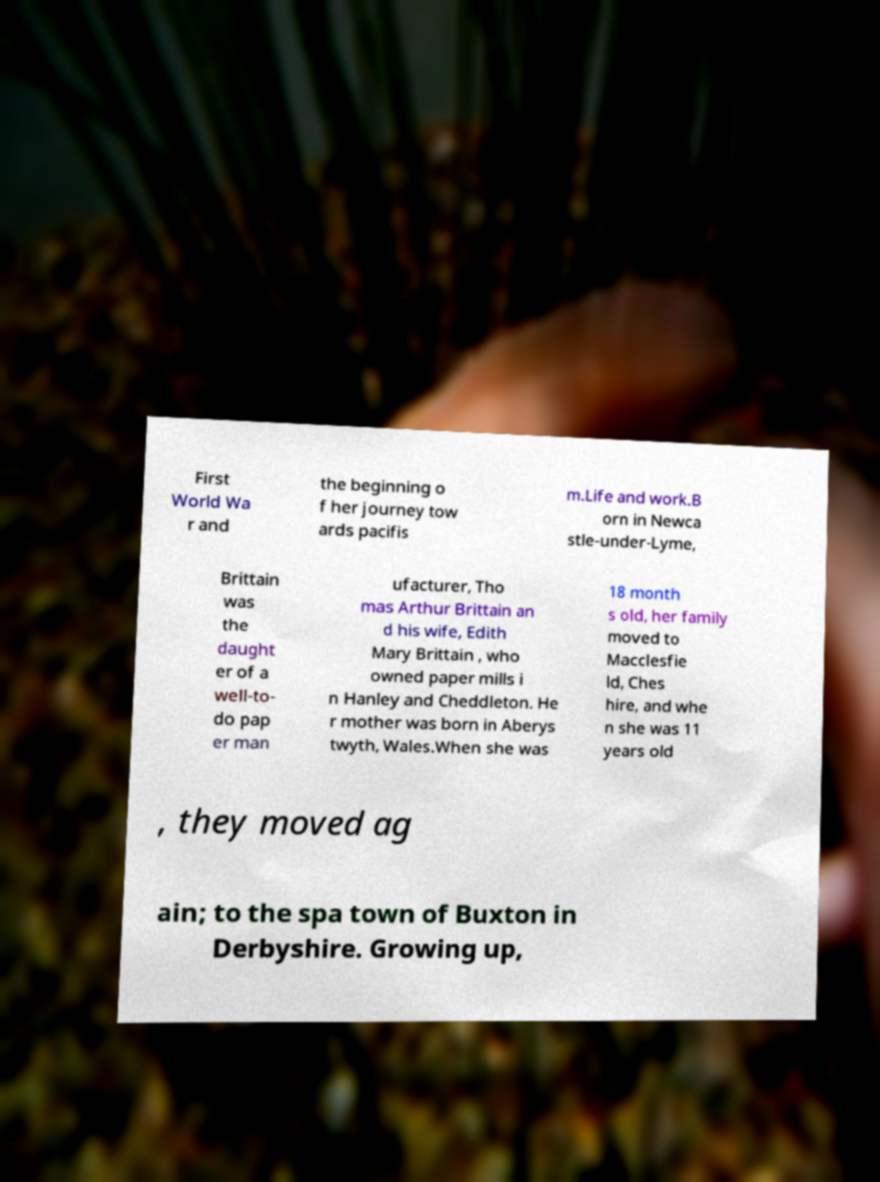Could you extract and type out the text from this image? First World Wa r and the beginning o f her journey tow ards pacifis m.Life and work.B orn in Newca stle-under-Lyme, Brittain was the daught er of a well-to- do pap er man ufacturer, Tho mas Arthur Brittain an d his wife, Edith Mary Brittain , who owned paper mills i n Hanley and Cheddleton. He r mother was born in Aberys twyth, Wales.When she was 18 month s old, her family moved to Macclesfie ld, Ches hire, and whe n she was 11 years old , they moved ag ain; to the spa town of Buxton in Derbyshire. Growing up, 